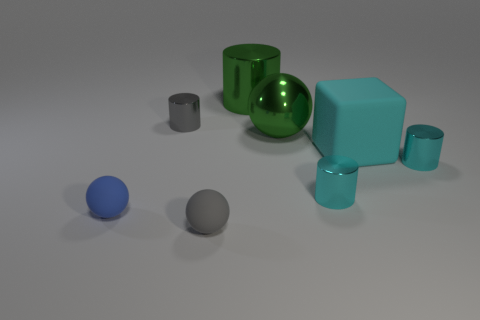There is a large shiny object in front of the gray shiny cylinder; is it the same color as the large cylinder?
Make the answer very short. Yes. Is there a metal thing that has the same size as the green cylinder?
Your answer should be compact. Yes. What is the color of the big thing that is made of the same material as the green ball?
Your answer should be very brief. Green. Are there fewer small yellow matte blocks than big green objects?
Your answer should be very brief. Yes. There is a small thing that is both left of the large green cylinder and right of the gray metal thing; what is its material?
Provide a succinct answer. Rubber. There is a gray object in front of the cube; is there a tiny metal thing that is to the left of it?
Keep it short and to the point. Yes. What number of large shiny cylinders have the same color as the large sphere?
Your answer should be very brief. 1. What is the material of the sphere that is the same color as the large metal cylinder?
Offer a terse response. Metal. Are the tiny gray cylinder and the tiny blue thing made of the same material?
Provide a succinct answer. No. Are there any big cyan matte things behind the large cyan matte block?
Ensure brevity in your answer.  No. 